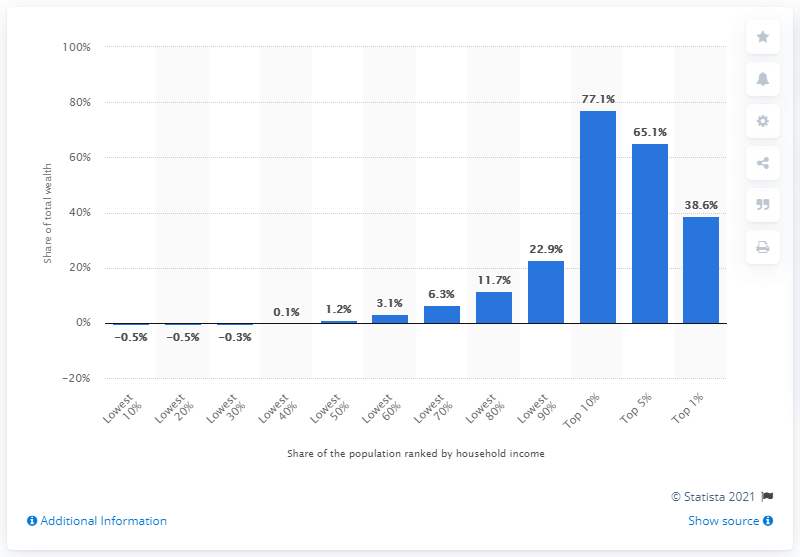Draw attention to some important aspects in this diagram. In 2016, the top 10 percent of earners in the United States owned approximately 77.1% of the country's wealth. The lowest 50 percent of earners owned only 1.2 percent of the total wealth in the country. 